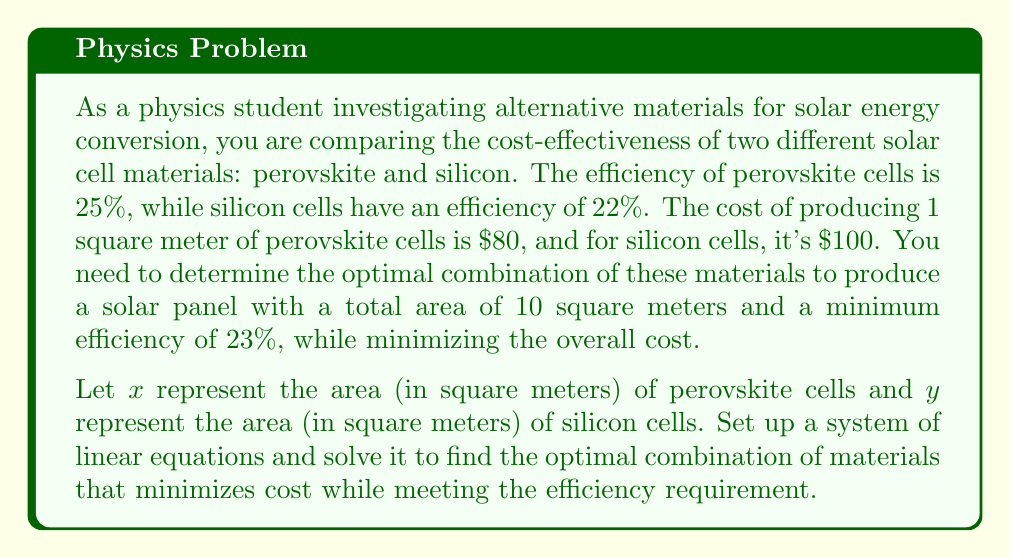Could you help me with this problem? To solve this problem, we need to set up a system of linear equations based on the given constraints and then minimize the cost function. Let's approach this step-by-step:

1. Total area constraint:
   The total area of the solar panel should be 10 square meters.
   $$x + y = 10$$

2. Efficiency constraint:
   The weighted average efficiency should be at least 23%.
   $$\frac{0.25x + 0.22y}{x + y} \geq 0.23$$
   
   Simplifying this inequality:
   $$0.25x + 0.22y \geq 0.23(x + y)$$
   $$0.25x + 0.22y \geq 0.23x + 0.23y$$
   $$0.02x \geq 0.01y$$
   $$2x \geq y$$

3. Cost function:
   The total cost is $80x + $100y, which we want to minimize.

Now we have a system of linear inequalities:
$$\begin{cases}
x + y = 10 \\
2x \geq y
\end{cases}$$

To minimize cost, we should use as much of the cheaper material (perovskite) as possible while still meeting the efficiency requirement. This occurs at the boundary of the efficiency constraint, where $2x = y$.

Substituting this into the area constraint:
$$x + 2x = 10$$
$$3x = 10$$
$$x = \frac{10}{3} \approx 3.33$$

Therefore:
$$y = 10 - x = 10 - \frac{10}{3} = \frac{20}{3} \approx 6.67$$

We can verify that this solution satisfies both constraints:
1. $3.33 + 6.67 = 10$ (total area)
2. $2(3.33) = 6.66 \approx 6.67$ (efficiency requirement)

The minimum cost is:
$$80(\frac{10}{3}) + 100(\frac{20}{3}) = \frac{2666.67}{3} \approx $888.89$$
Answer: The optimal combination is approximately 3.33 square meters of perovskite cells and 6.67 square meters of silicon cells, resulting in a minimum cost of about $888.89. 